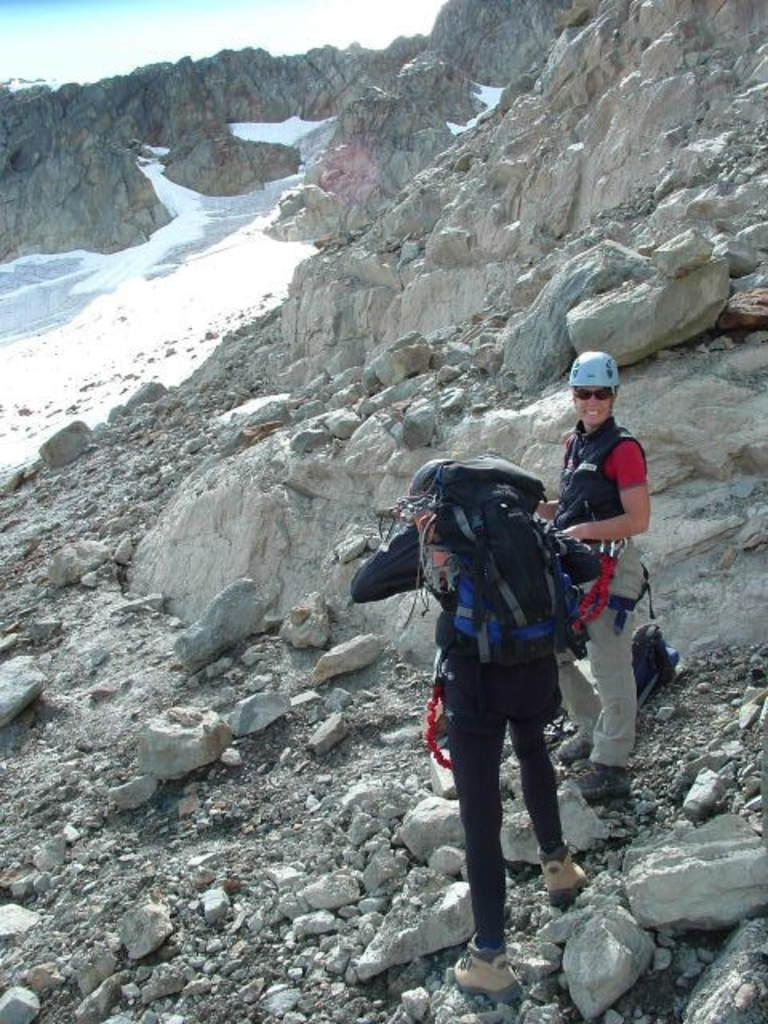Who or what can be seen in the image? There are people in the image. What else is present in the image besides the people? There are rocks in the image. Can you describe the actions of one of the people in the image? One person is carrying a bag. What type of bomb can be seen in the image? There is no bomb present in the image. Can you tell me who is playing chess with whom in the image? There is no chess game depicted in the image. 